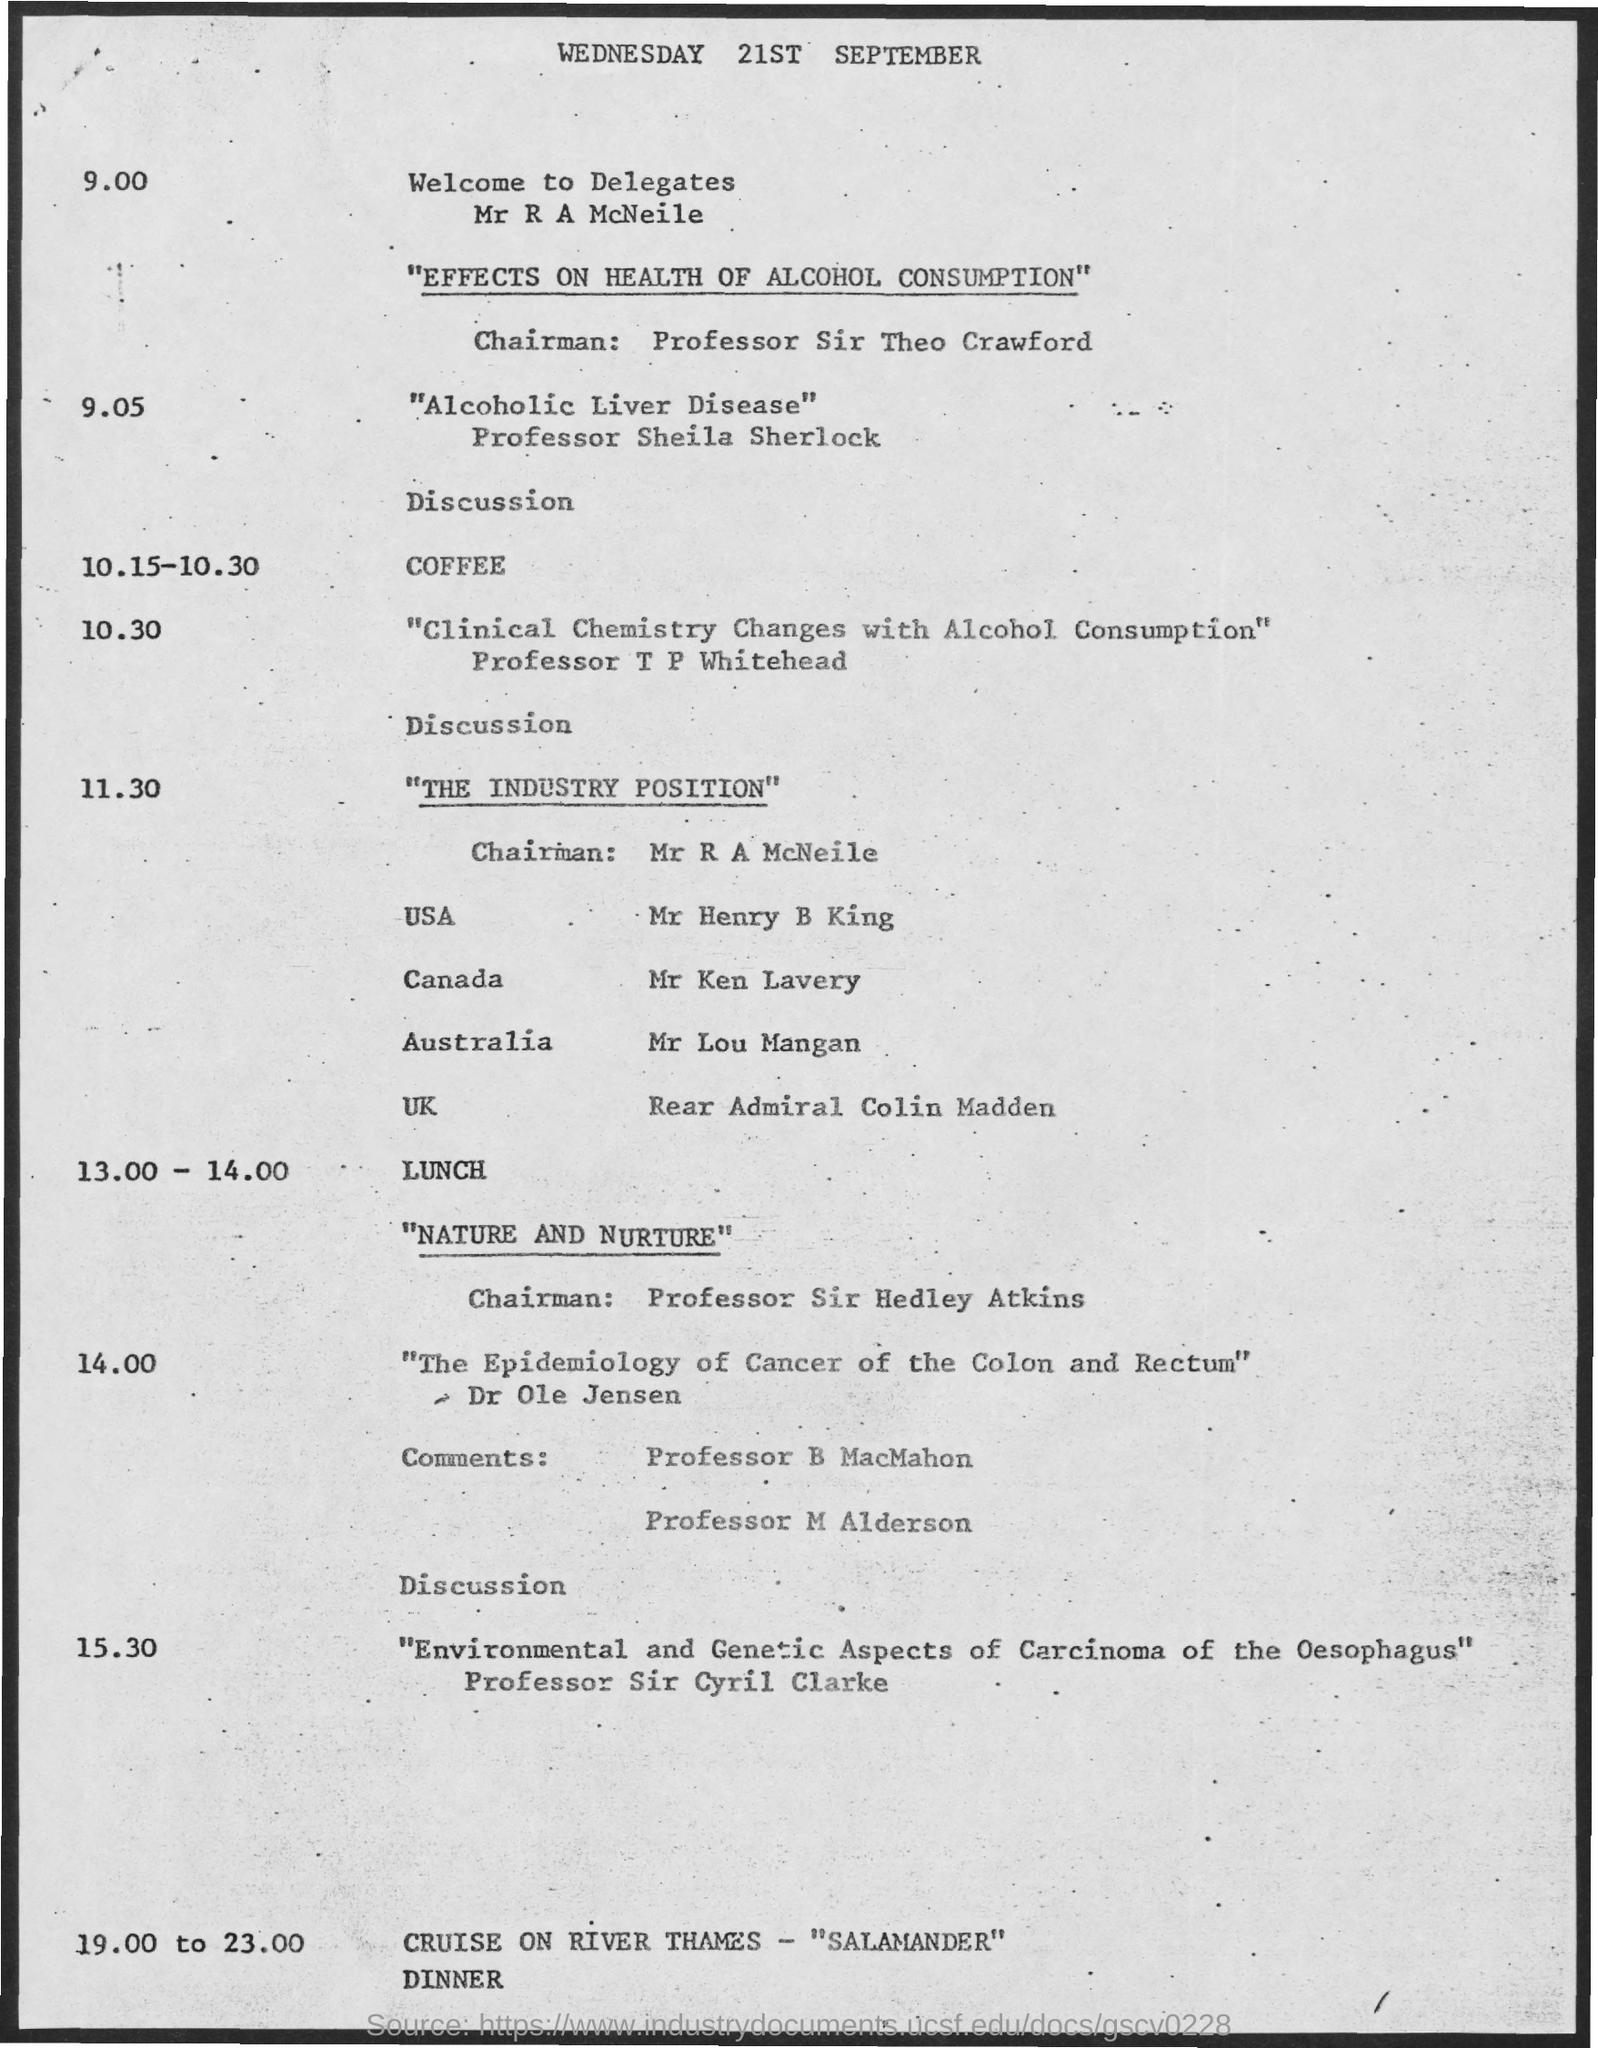What is the date mentioned in the document?
Your answer should be compact. 21st september. 